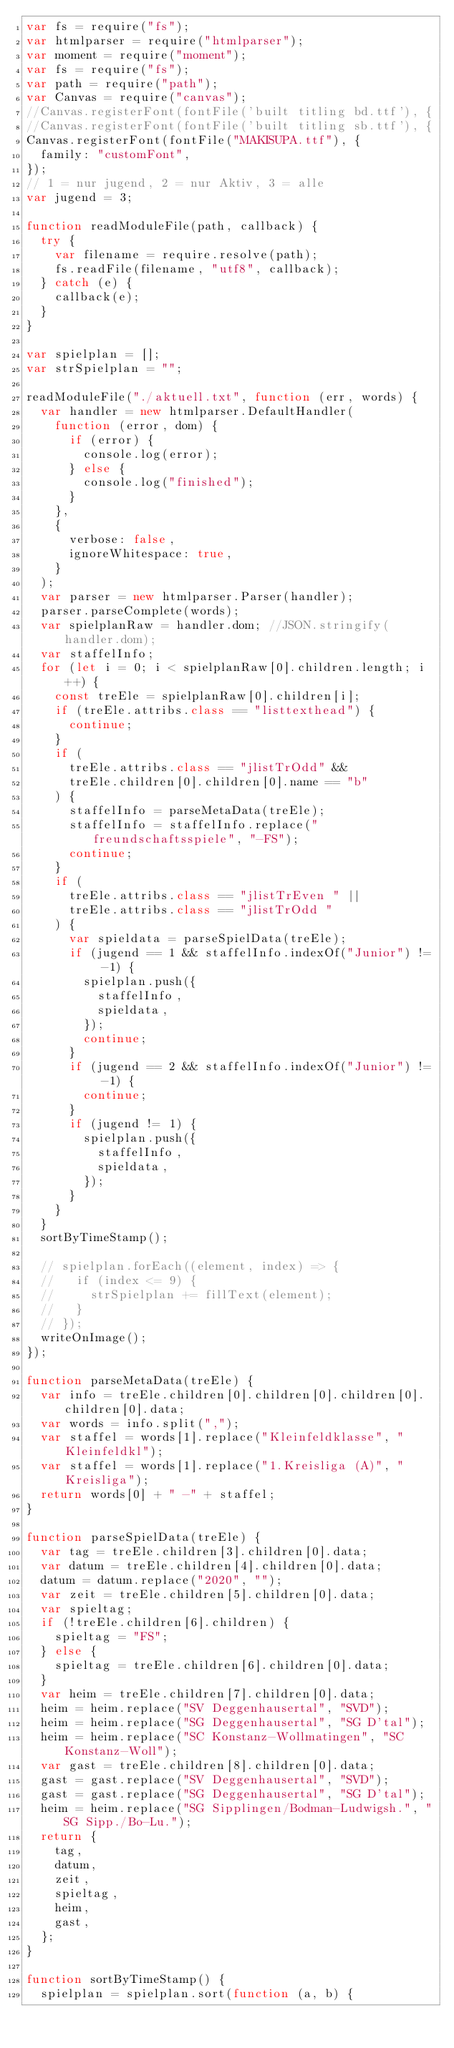Convert code to text. <code><loc_0><loc_0><loc_500><loc_500><_JavaScript_>var fs = require("fs");
var htmlparser = require("htmlparser");
var moment = require("moment");
var fs = require("fs");
var path = require("path");
var Canvas = require("canvas");
//Canvas.registerFont(fontFile('built titling bd.ttf'), {
//Canvas.registerFont(fontFile('built titling sb.ttf'), {
Canvas.registerFont(fontFile("MAKISUPA.ttf"), {
  family: "customFont",
});
// 1 = nur jugend, 2 = nur Aktiv, 3 = alle
var jugend = 3;

function readModuleFile(path, callback) {
  try {
    var filename = require.resolve(path);
    fs.readFile(filename, "utf8", callback);
  } catch (e) {
    callback(e);
  }
}

var spielplan = [];
var strSpielplan = "";

readModuleFile("./aktuell.txt", function (err, words) {
  var handler = new htmlparser.DefaultHandler(
    function (error, dom) {
      if (error) {
        console.log(error);
      } else {
        console.log("finished");
      }
    },
    {
      verbose: false,
      ignoreWhitespace: true,
    }
  );
  var parser = new htmlparser.Parser(handler);
  parser.parseComplete(words);
  var spielplanRaw = handler.dom; //JSON.stringify(handler.dom);
  var staffelInfo;
  for (let i = 0; i < spielplanRaw[0].children.length; i++) {
    const treEle = spielplanRaw[0].children[i];
    if (treEle.attribs.class == "listtexthead") {
      continue;
    }
    if (
      treEle.attribs.class == "jlistTrOdd" &&
      treEle.children[0].children[0].name == "b"
    ) {
      staffelInfo = parseMetaData(treEle);
      staffelInfo = staffelInfo.replace("freundschaftsspiele", "-FS");
      continue;
    }
    if (
      treEle.attribs.class == "jlistTrEven " ||
      treEle.attribs.class == "jlistTrOdd "
    ) {
      var spieldata = parseSpielData(treEle);
      if (jugend == 1 && staffelInfo.indexOf("Junior") != -1) {
        spielplan.push({
          staffelInfo,
          spieldata,
        });
        continue;
      }
      if (jugend == 2 && staffelInfo.indexOf("Junior") != -1) {
        continue;
      }
      if (jugend != 1) {
        spielplan.push({
          staffelInfo,
          spieldata,
        });
      }
    }
  }
  sortByTimeStamp();

  // spielplan.forEach((element, index) => {
  //   if (index <= 9) {
  //     strSpielplan += fillText(element);
  //   }
  // });
  writeOnImage();
});

function parseMetaData(treEle) {
  var info = treEle.children[0].children[0].children[0].children[0].data;
  var words = info.split(",");
  var staffel = words[1].replace("Kleinfeldklasse", "Kleinfeldkl");
  var staffel = words[1].replace("1.Kreisliga (A)", "Kreisliga");
  return words[0] + " -" + staffel;
}

function parseSpielData(treEle) {
  var tag = treEle.children[3].children[0].data;
  var datum = treEle.children[4].children[0].data;
  datum = datum.replace("2020", "");
  var zeit = treEle.children[5].children[0].data;
  var spieltag;
  if (!treEle.children[6].children) {
    spieltag = "FS";
  } else {
    spieltag = treEle.children[6].children[0].data;
  }
  var heim = treEle.children[7].children[0].data;
  heim = heim.replace("SV Deggenhausertal", "SVD");
  heim = heim.replace("SG Deggenhausertal", "SG D'tal");
  heim = heim.replace("SC Konstanz-Wollmatingen", "SC Konstanz-Woll");
  var gast = treEle.children[8].children[0].data;
  gast = gast.replace("SV Deggenhausertal", "SVD");
  gast = gast.replace("SG Deggenhausertal", "SG D'tal");
  heim = heim.replace("SG Sipplingen/Bodman-Ludwigsh.", "SG Sipp./Bo-Lu.");
  return {
    tag,
    datum,
    zeit,
    spieltag,
    heim,
    gast,
  };
}

function sortByTimeStamp() {
  spielplan = spielplan.sort(function (a, b) {</code> 